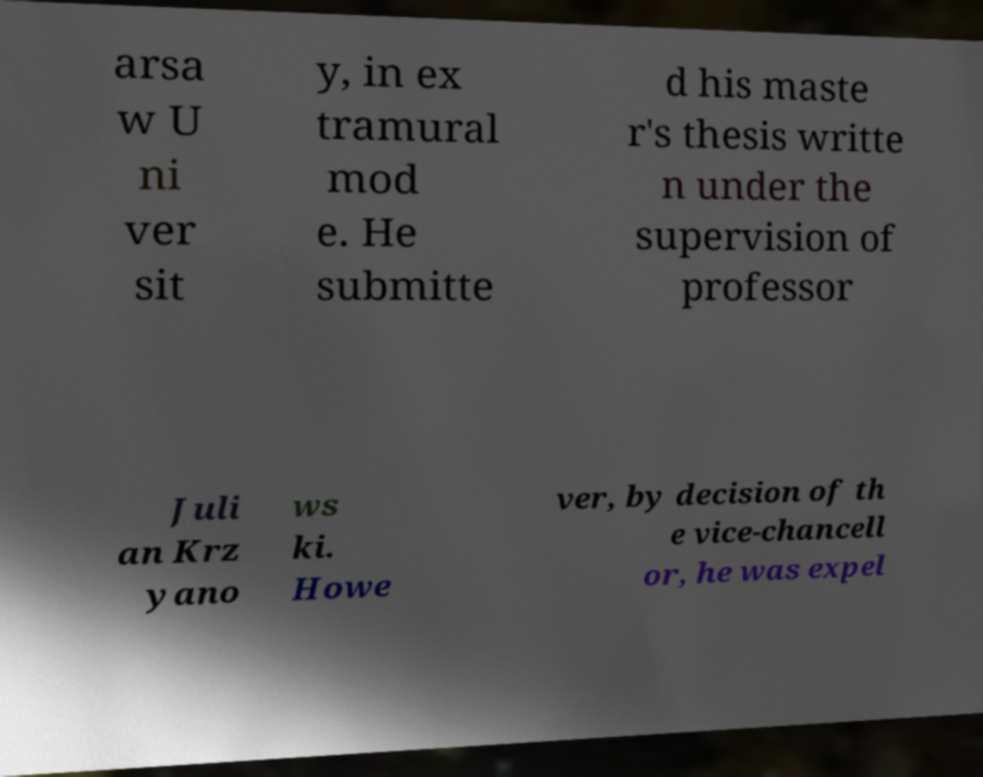There's text embedded in this image that I need extracted. Can you transcribe it verbatim? arsa w U ni ver sit y, in ex tramural mod e. He submitte d his maste r's thesis writte n under the supervision of professor Juli an Krz yano ws ki. Howe ver, by decision of th e vice-chancell or, he was expel 